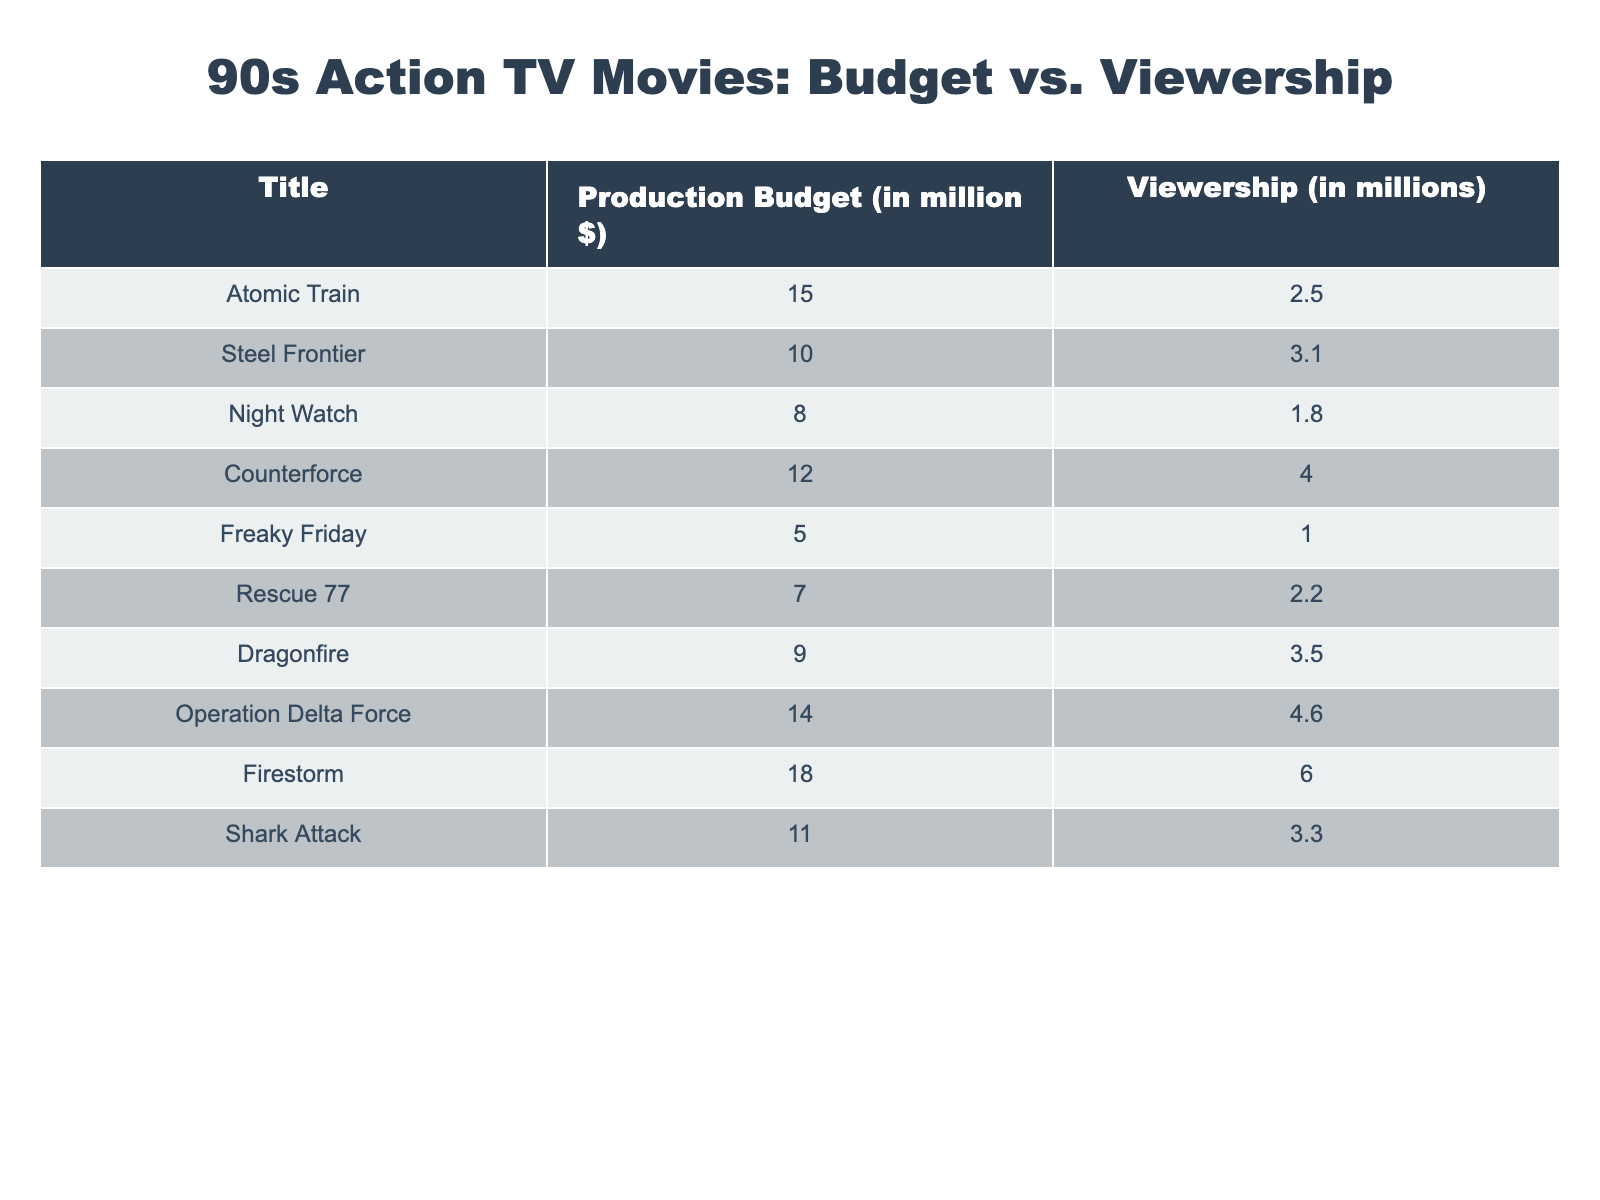What is the production budget for "Firestorm"? The table lists "Firestorm" with a production budget of 18 million dollars.
Answer: 18 million What is the total viewership for "Operation Delta Force" and "Counterforce"? "Operation Delta Force" has viewership of 4.6 million and "Counterforce" has viewership of 4.0 million. Adding these gives 4.6 + 4.0 = 8.6 million.
Answer: 8.6 million Is the production budget of "Shark Attack" greater than the viewership of "Night Watch"? The production budget for "Shark Attack" is 11 million, and its viewership is 3.3 million; also, "Night Watch" has a budget of 8 million and a viewership of 1.8 million. Since 11 million is greater than 1.8 million, the statement is true.
Answer: Yes Which movie had the lowest viewership? The table shows "Freaky Friday" with a viewership of 1.0 million, which is the lowest among all listed movies.
Answer: "Freaky Friday" What is the average viewership of the movies with budgets greater than 10 million? The movies with budgets greater than 10 million are "Atomic Train," "Counterforce," "Operation Delta Force," and "Firestorm," which have viewerships of 2.5, 4.0, 4.6, and 6.0 million respectively. Adding these gives 2.5 + 4.0 + 4.6 + 6.0 = 17.1 million. Dividing by the number of movies (4) gives 17.1 / 4 = 4.275 million.
Answer: 4.275 million Is there a movie with a production budget of exactly 10 million? Looking at the table, "Steel Frontier" has a production budget of exactly 10 million dollars. Therefore, the answer is yes.
Answer: Yes Which movie has the highest production budget and how much is it? "Firestorm" has the highest production budget listed at 18 million dollars, making it the movie with the largest budget among those presented.
Answer: "Firestorm", 18 million What is the difference between the highest and lowest viewership numbers? The highest viewership is 6 million ("Firestorm") and the lowest is 1 million ("Freaky Friday"). The difference is calculated as 6 - 1 = 5 million.
Answer: 5 million How many movies have a viewership greater than 3 million? Reviewing the table, the movies with a viewership greater than 3 million are "Counterforce," "Operation Delta Force," "Firestorm," and "Steel Frontier," totaling four movies in this group.
Answer: 4 movies 